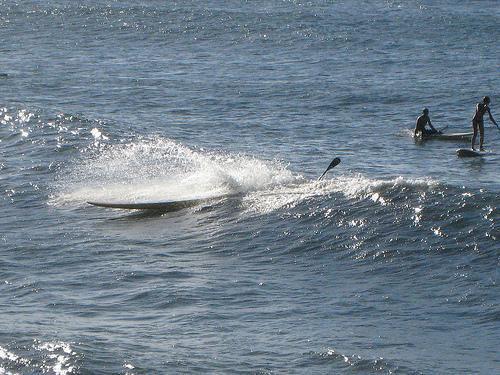How many people are shown?
Give a very brief answer. 2. 